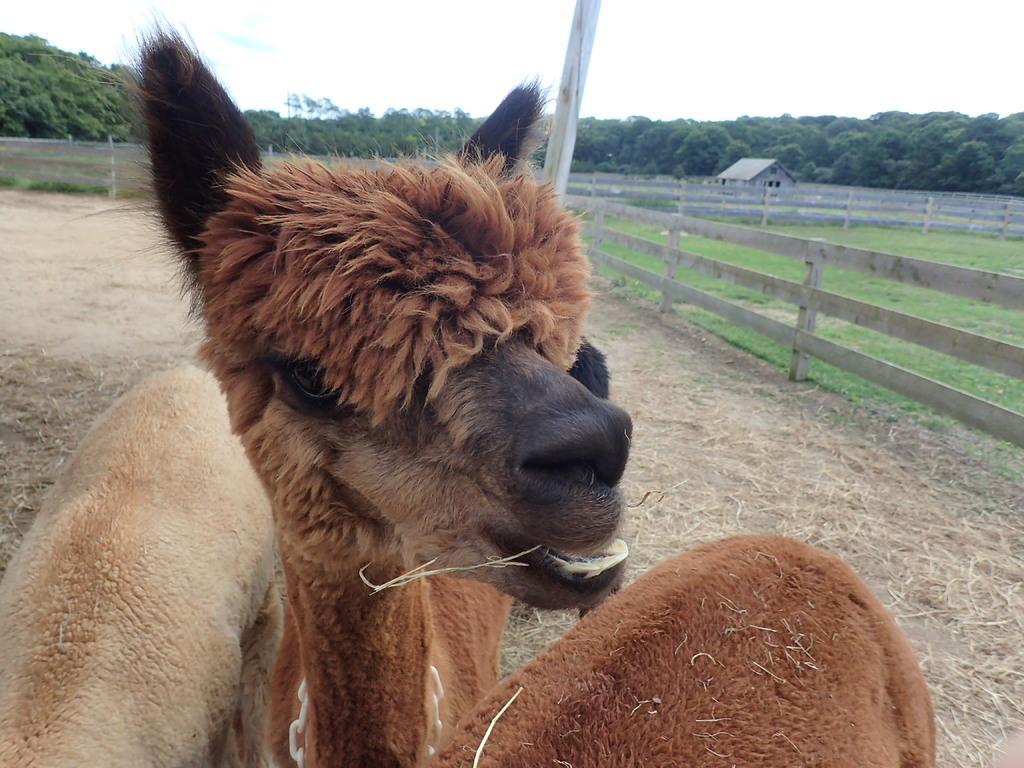How would you summarize this image in a sentence or two? In the center of the image, we can see animals and in the background, there is a fence , shed, a pole and we can see many trees. At the bottom, there is ground. 